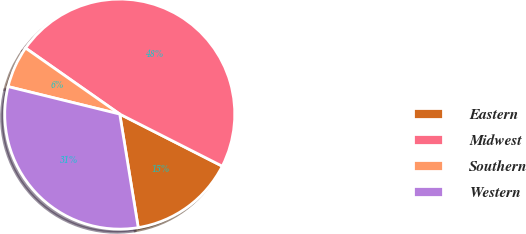Convert chart to OTSL. <chart><loc_0><loc_0><loc_500><loc_500><pie_chart><fcel>Eastern<fcel>Midwest<fcel>Southern<fcel>Western<nl><fcel>14.95%<fcel>47.75%<fcel>5.89%<fcel>31.41%<nl></chart> 